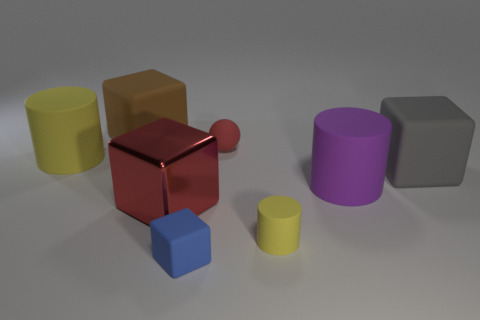What shape is the tiny object that is behind the cylinder in front of the red block?
Your answer should be very brief. Sphere. The brown thing that is the same shape as the large gray rubber thing is what size?
Provide a succinct answer. Large. Is there anything else that has the same size as the purple rubber cylinder?
Your response must be concise. Yes. What color is the big cylinder right of the large yellow rubber thing?
Offer a very short reply. Purple. What material is the large object that is on the left side of the large rubber cube that is behind the big thing to the left of the brown block?
Offer a very short reply. Rubber. How big is the red object behind the gray rubber thing that is on the right side of the big red cube?
Your answer should be very brief. Small. What is the color of the other big rubber thing that is the same shape as the purple rubber object?
Provide a short and direct response. Yellow. How many large rubber cubes have the same color as the big shiny object?
Give a very brief answer. 0. Does the sphere have the same size as the brown thing?
Offer a very short reply. No. What is the gray object made of?
Your response must be concise. Rubber. 